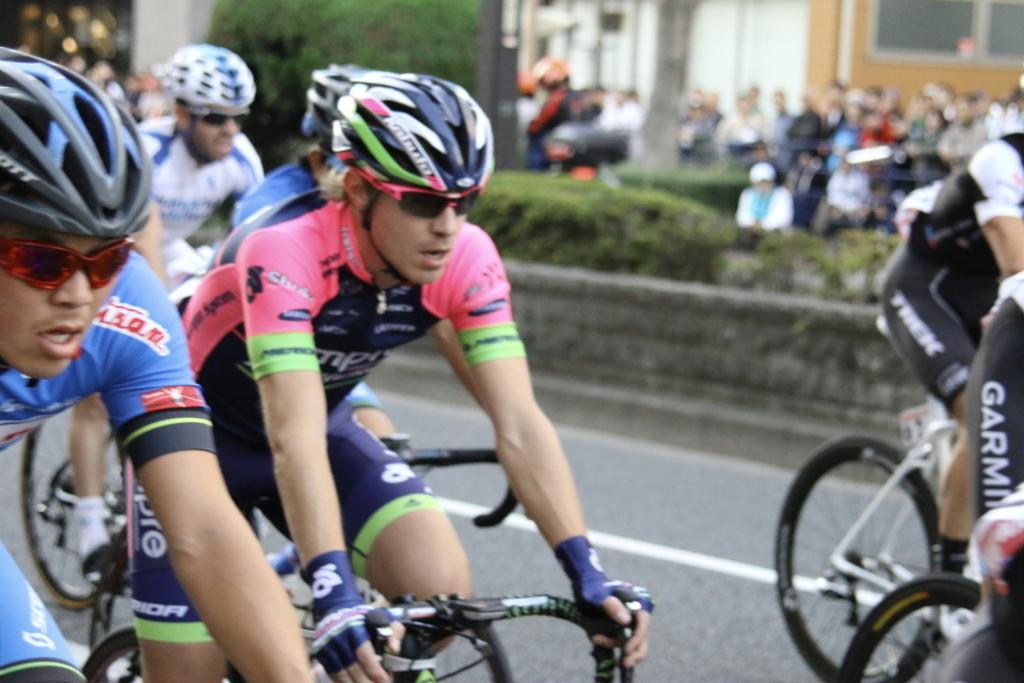How would you summarize this image in a sentence or two? In the front of the image I can see people are holding bicycles and wore helmets. In the background of the image it is blurry. I can see a tree, plants and people.   